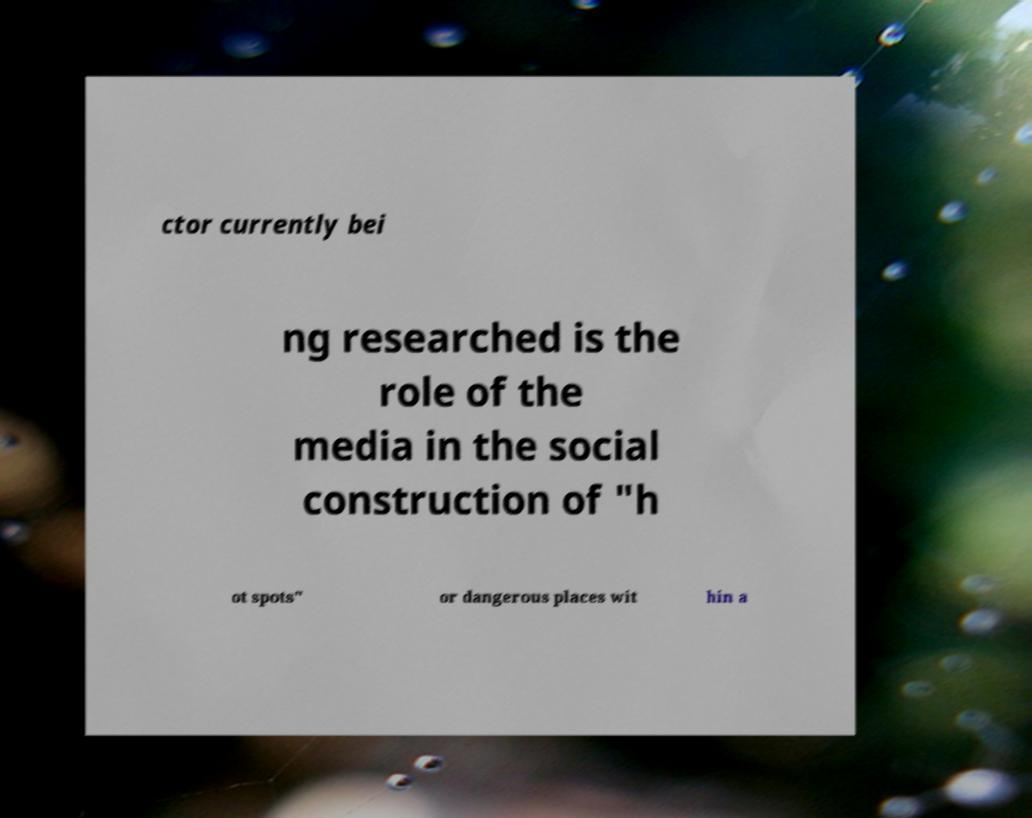Please read and relay the text visible in this image. What does it say? ctor currently bei ng researched is the role of the media in the social construction of "h ot spots" or dangerous places wit hin a 